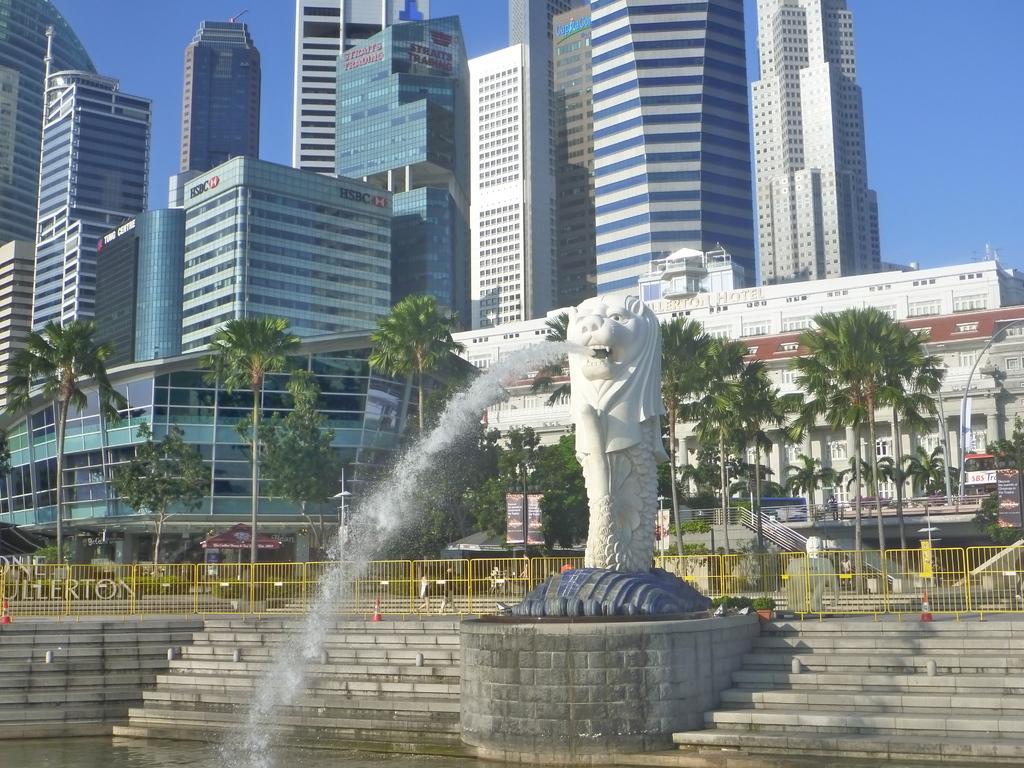Please provide a concise description of this image. In this image we can see a fountain, water, steps and fence. In the background there are trees, few persons walking, traffic cones, buildings, light poles, buildings, windows, glass doors, texts written on the buildings and sky. 